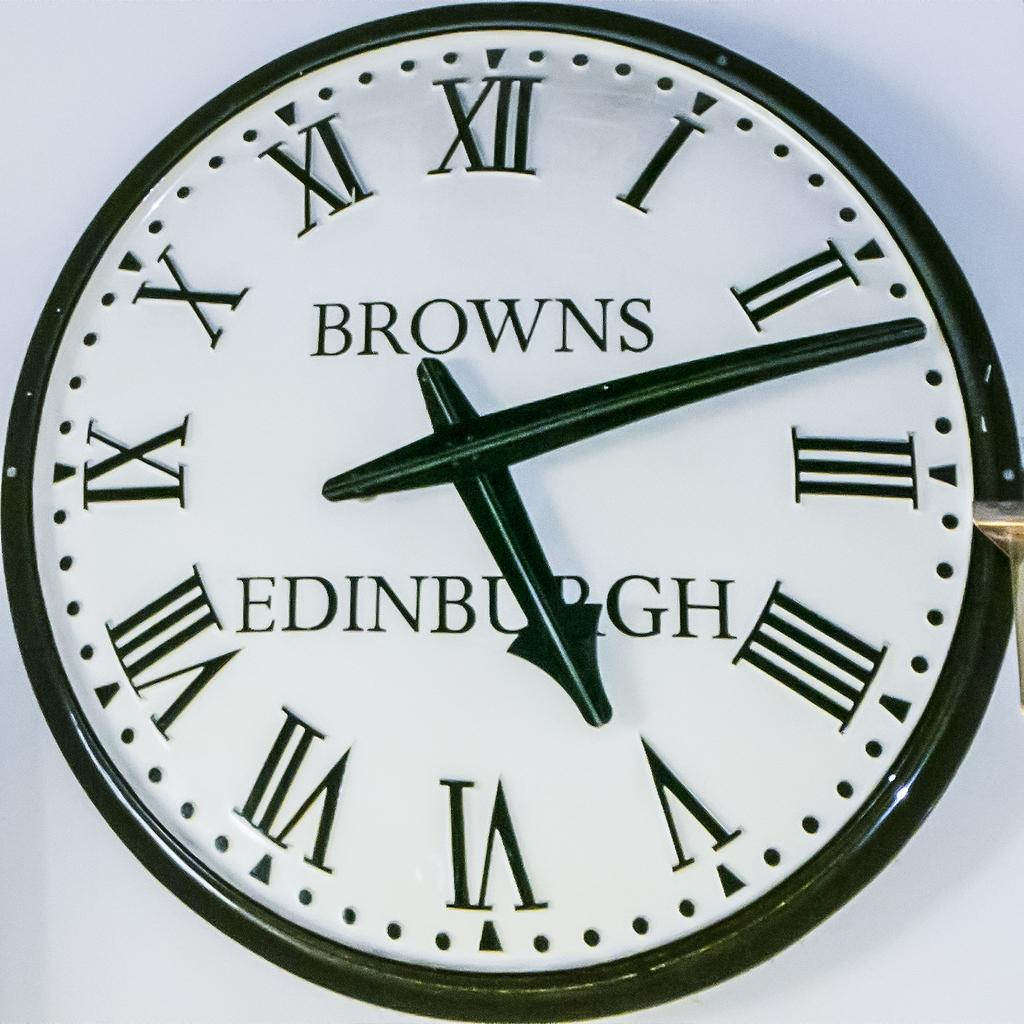<image>
Write a terse but informative summary of the picture. Clock which says Browns Edinburgh in black letters. 